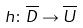<formula> <loc_0><loc_0><loc_500><loc_500>h \colon \overline { D } \rightarrow \overline { U }</formula> 